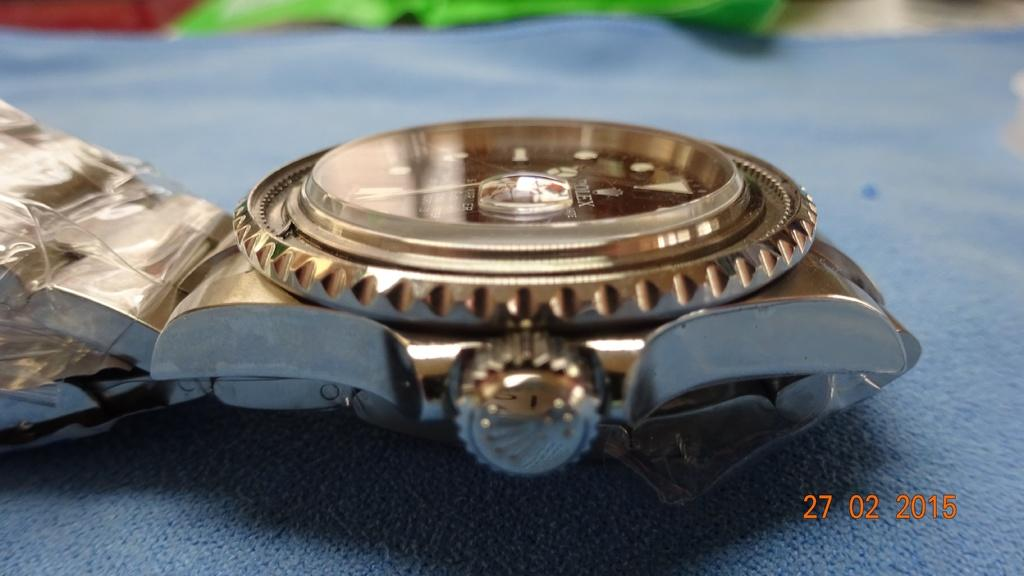<image>
Share a concise interpretation of the image provided. A gold watch from February 27, 2015 on a blue cloth. 